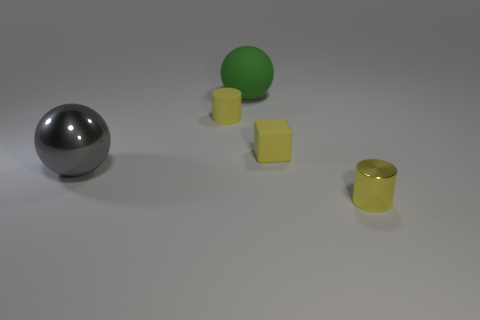The gray shiny ball is what size?
Provide a short and direct response. Large. How many cyan things are rubber objects or shiny cylinders?
Your response must be concise. 0. How many other metal objects have the same shape as the green thing?
Your answer should be very brief. 1. What number of yellow cylinders have the same size as the gray sphere?
Your response must be concise. 0. What is the material of the green thing that is the same shape as the gray metallic object?
Offer a terse response. Rubber. There is a tiny rubber thing that is to the left of the big rubber object; what is its color?
Your answer should be compact. Yellow. Are there more big rubber spheres that are in front of the rubber sphere than gray balls?
Provide a short and direct response. No. The tiny shiny thing is what color?
Ensure brevity in your answer.  Yellow. What is the shape of the metal object behind the small yellow cylinder that is right of the cylinder on the left side of the block?
Give a very brief answer. Sphere. There is a object that is both to the left of the big rubber sphere and in front of the block; what material is it?
Provide a succinct answer. Metal. 